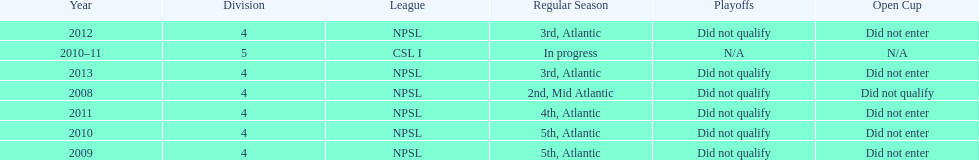What is the only year that is n/a? 2010-11. 